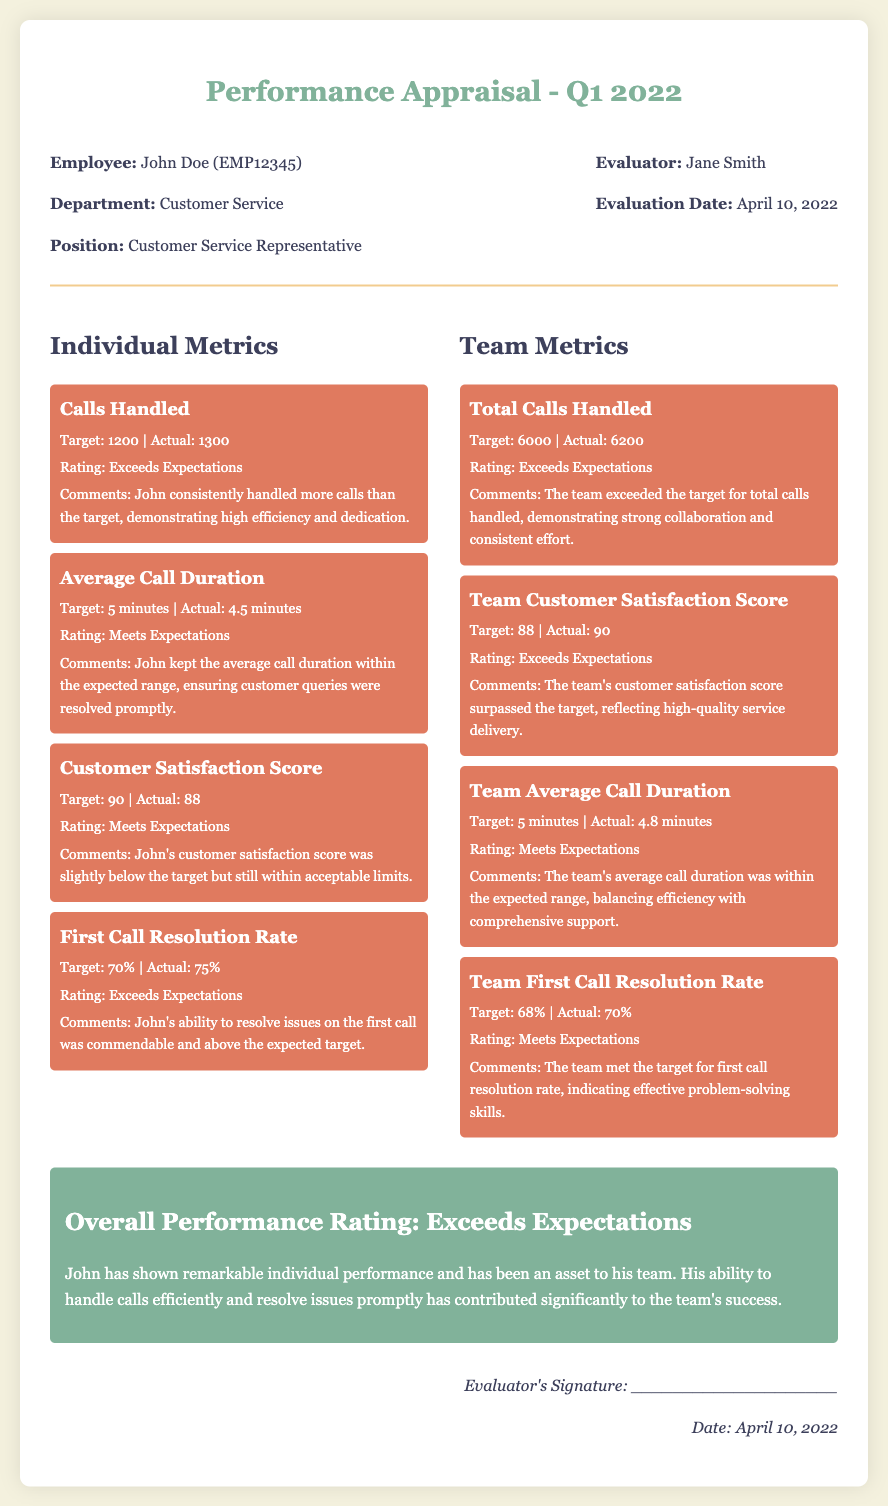What is the employee's name? The employee's name is stated in the header section of the document.
Answer: John Doe What is the position of the employee? The position is specified under the employee details in the document.
Answer: Customer Service Representative What is the target for First Call Resolution Rate? The target for First Call Resolution Rate is mentioned under the individual metrics.
Answer: 70% What was John's actual Customer Satisfaction Score? The actual score is mentioned in the individual metrics for Customer Satisfaction Score.
Answer: 88 How many total calls did the team handle? The total calls handled is listed in the team metrics section of the document.
Answer: 6200 What rating did John's calls handled metric receive? The rating is provided after the Calls Handled metric in the individual metrics section.
Answer: Exceeds Expectations What is the evaluation date? The evaluation date is shown in the header alongside the evaluators' information.
Answer: April 10, 2022 What is the team's rating for the Average Call Duration metric? The rating for Team Average Call Duration is indicated in the team metrics section.
Answer: Meets Expectations What did the overall performance rating state? The overall performance rating is summarized at the end of the document under the overall section.
Answer: Exceeds Expectations 